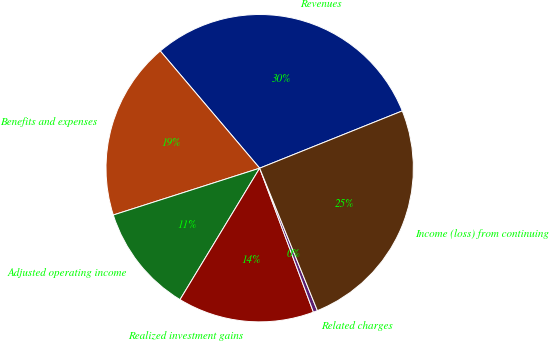<chart> <loc_0><loc_0><loc_500><loc_500><pie_chart><fcel>Revenues<fcel>Benefits and expenses<fcel>Adjusted operating income<fcel>Realized investment gains<fcel>Related charges<fcel>Income (loss) from continuing<nl><fcel>30.12%<fcel>18.73%<fcel>11.4%<fcel>14.36%<fcel>0.44%<fcel>24.95%<nl></chart> 